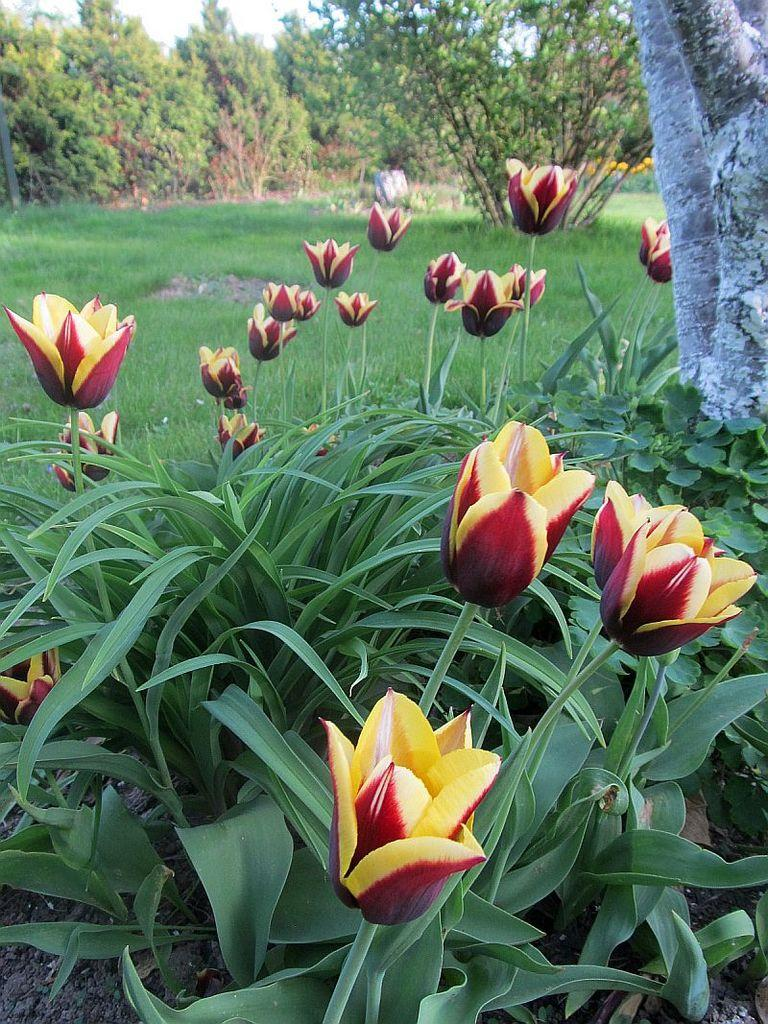What type of plants can be seen in the image? There are plants with flowers in the image. What type of vegetation is present at ground level? There is grass in the image. What can be seen in the background of the image? There are trees and the sky visible in the background of the image. How much force is required to join the cheese in the image? There is no cheese present in the image, so the question of force is not applicable. 